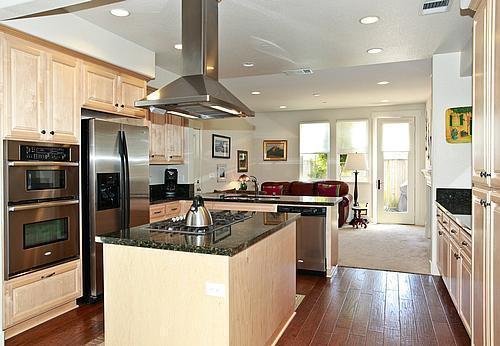How many ovens are there?
Give a very brief answer. 2. How many people probably used this workstation recently?
Give a very brief answer. 0. 